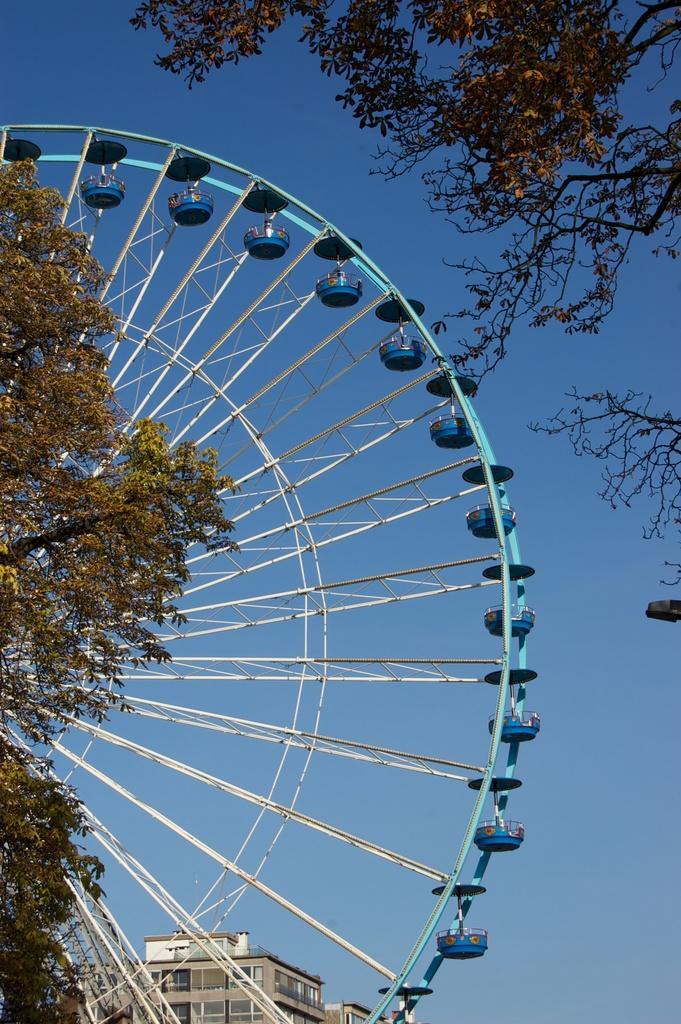How would you summarize this image in a sentence or two? In the foreground of the picture there are trees. In the center of the picture there is a ferrous wheel. In the background there are buildings. In this picture we can see sky. 